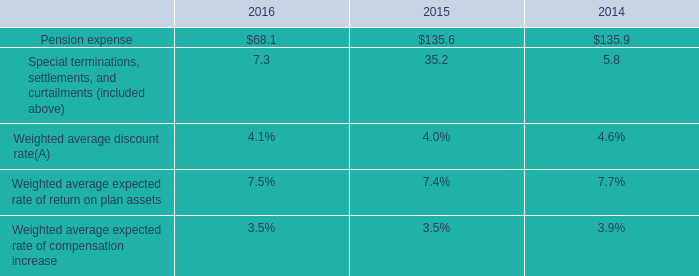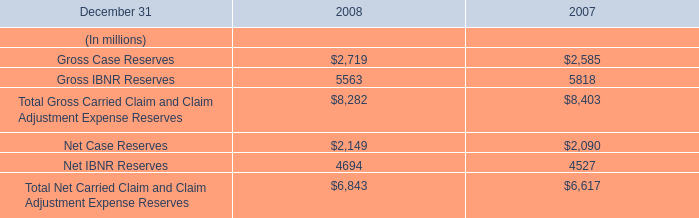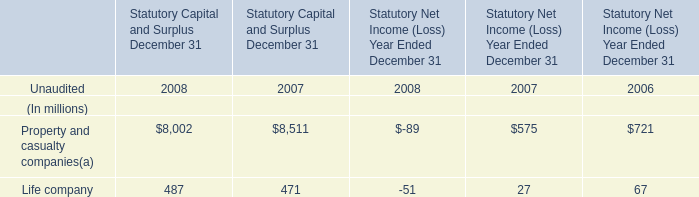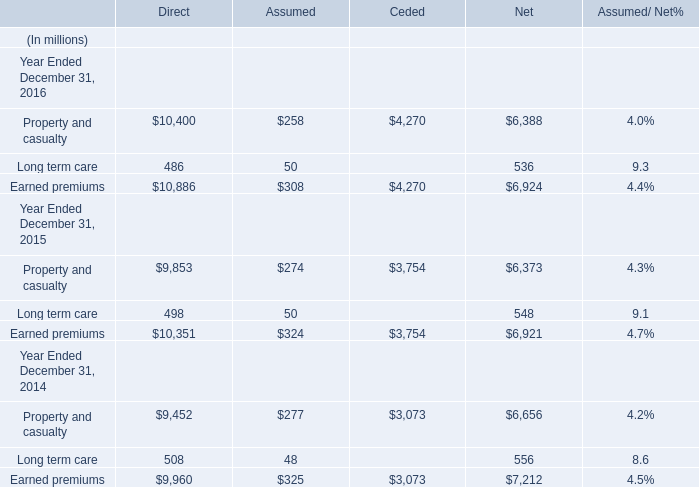What's the average of Net IBNR Reserves of 2008, and Property and casualty Year Ended December 31, 2015 of Net ? 
Computations: ((4694.0 + 6373.0) / 2)
Answer: 5533.5. 